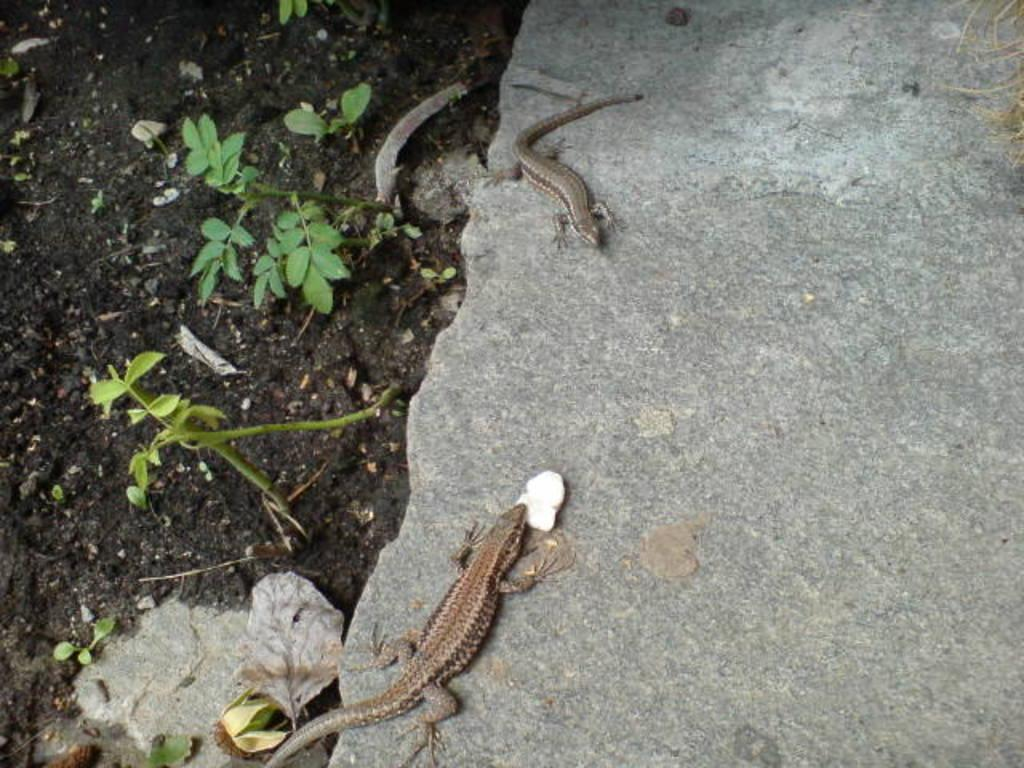What animals can be seen on the rock in the image? There are two lizards on the surface of a rock in the image. What type of vegetation is present on the ground? Some plants are present on the ground in the image. How does the beggar feel about the lizards in the image? There is no beggar present in the image, so it is not possible to determine how they might feel about the lizards. 